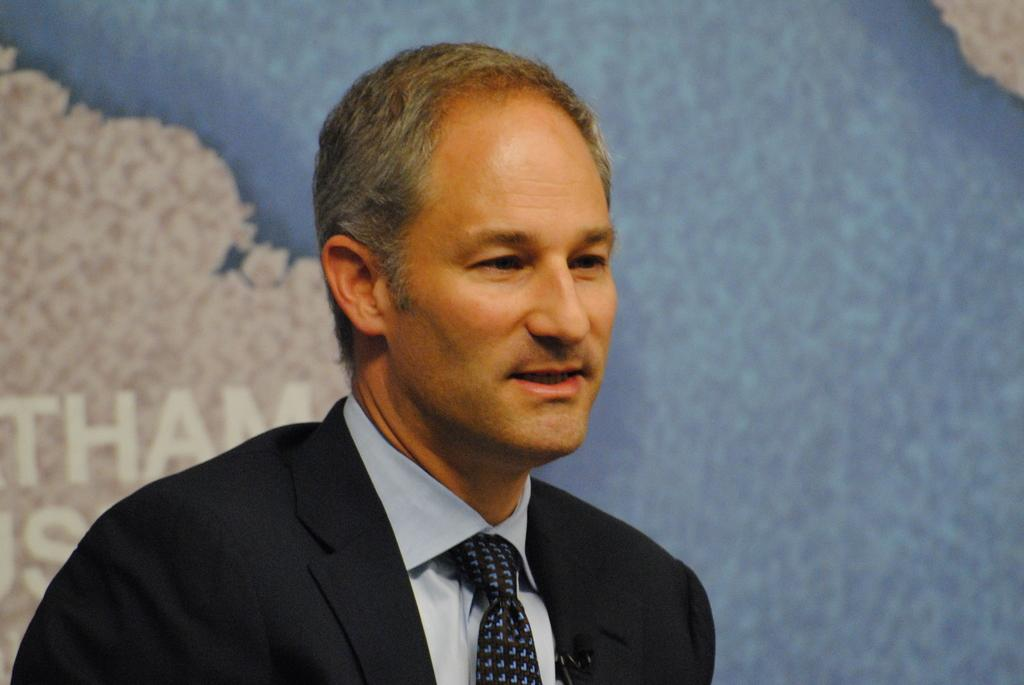Who is present in the image? There is a man in the image. What is the man wearing? The man is wearing a black suit and a tie. What can be seen in the background of the image? There is a map in the background of the image. Can you see any beans on the man's plate in the image? There is no plate or beans present in the image. Is the man standing near the seashore in the image? There is no indication of a seashore or any body of water in the image. 